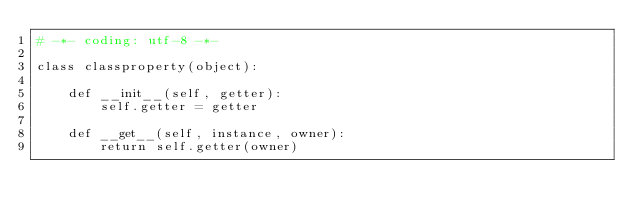Convert code to text. <code><loc_0><loc_0><loc_500><loc_500><_Python_># -*- coding: utf-8 -*-

class classproperty(object):

    def __init__(self, getter):
        self.getter = getter

    def __get__(self, instance, owner):
        return self.getter(owner)</code> 